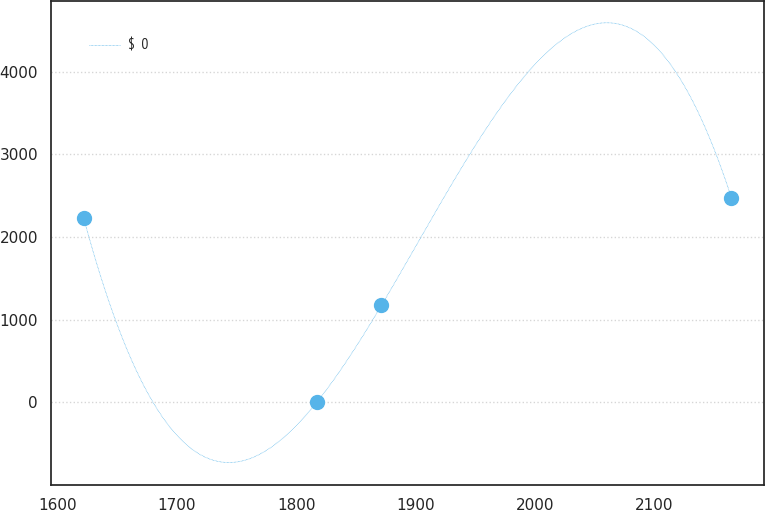Convert chart to OTSL. <chart><loc_0><loc_0><loc_500><loc_500><line_chart><ecel><fcel>$  0<nl><fcel>1621.95<fcel>2233.5<nl><fcel>1817.21<fcel>0<nl><fcel>1871.48<fcel>1172.38<nl><fcel>2164.68<fcel>2477.03<nl></chart> 